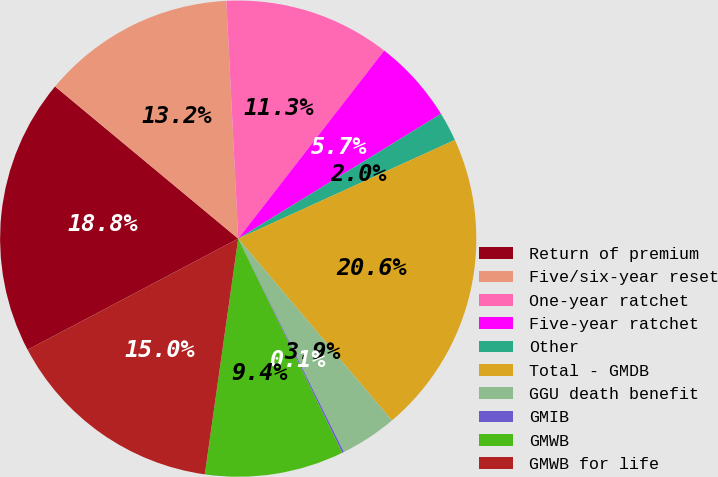Convert chart to OTSL. <chart><loc_0><loc_0><loc_500><loc_500><pie_chart><fcel>Return of premium<fcel>Five/six-year reset<fcel>One-year ratchet<fcel>Five-year ratchet<fcel>Other<fcel>Total - GMDB<fcel>GGU death benefit<fcel>GMIB<fcel>GMWB<fcel>GMWB for life<nl><fcel>18.76%<fcel>13.17%<fcel>11.3%<fcel>5.71%<fcel>1.98%<fcel>20.63%<fcel>3.85%<fcel>0.12%<fcel>9.44%<fcel>15.03%<nl></chart> 